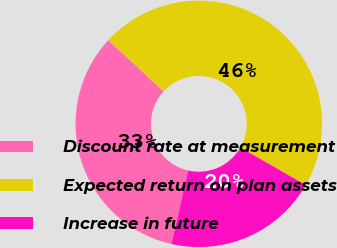Convert chart. <chart><loc_0><loc_0><loc_500><loc_500><pie_chart><fcel>Discount rate at measurement<fcel>Expected return on plan assets<fcel>Increase in future<nl><fcel>33.33%<fcel>46.38%<fcel>20.29%<nl></chart> 